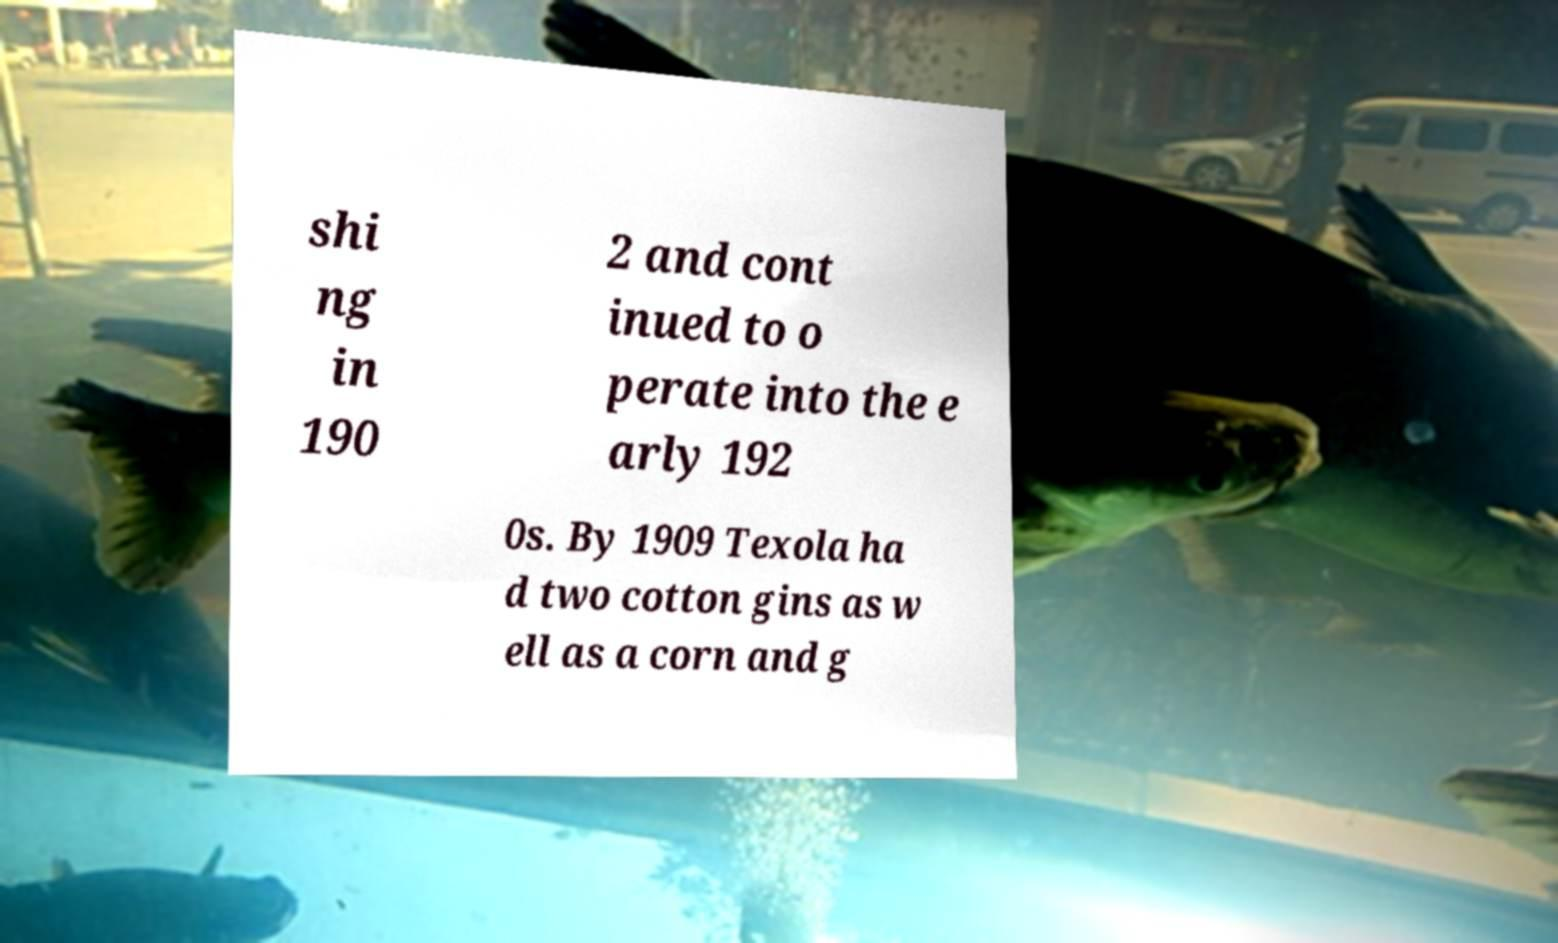For documentation purposes, I need the text within this image transcribed. Could you provide that? shi ng in 190 2 and cont inued to o perate into the e arly 192 0s. By 1909 Texola ha d two cotton gins as w ell as a corn and g 